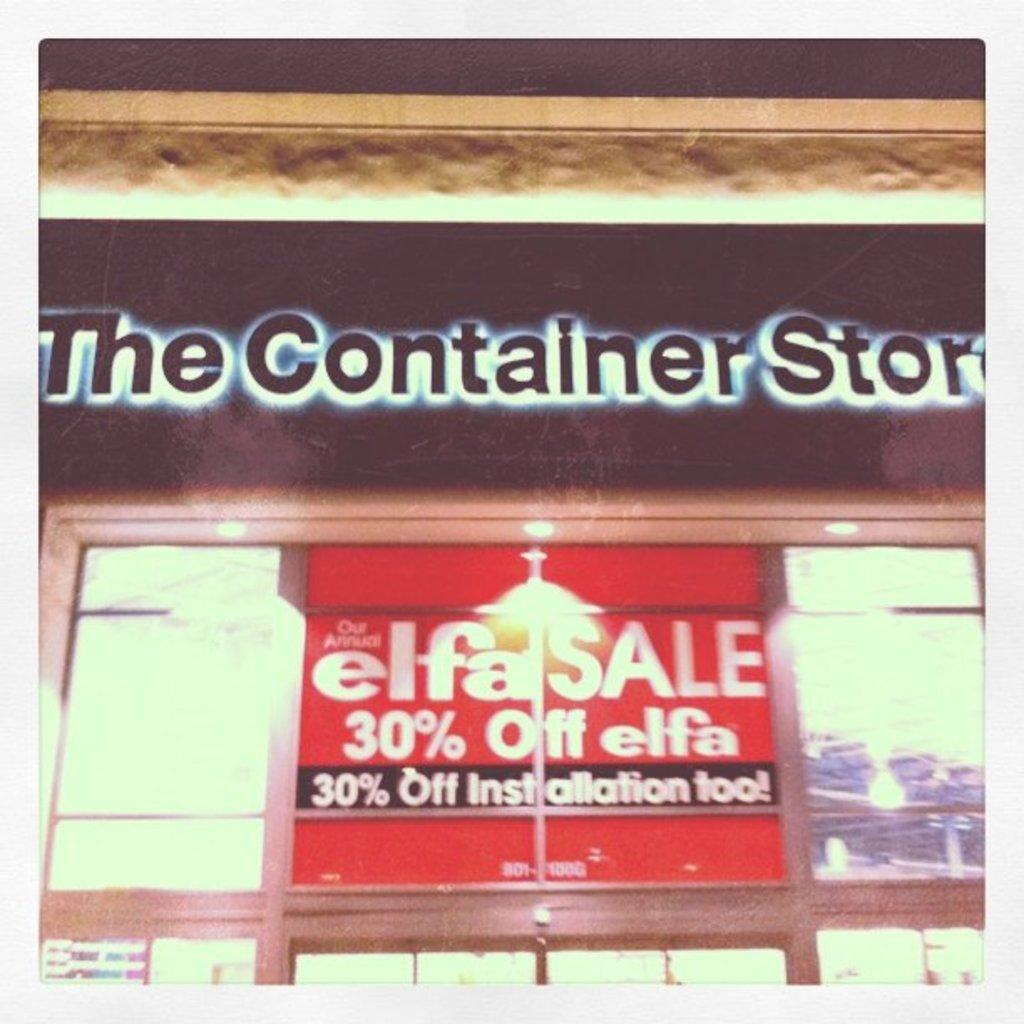<image>
Share a concise interpretation of the image provided. the exterior of THE Container STORE with a sign for a SALE 